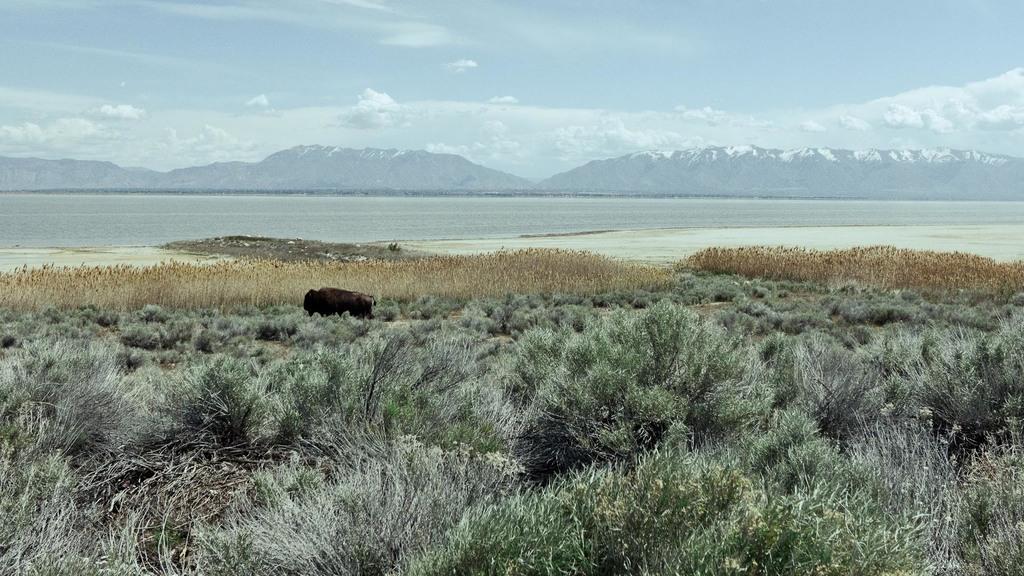Please provide a concise description of this image. In this image there are so many plants at the bottom. In between the plants there is an animal. In the middle it looks like a sea. In the background there are mountains. At the top there is the sky. 